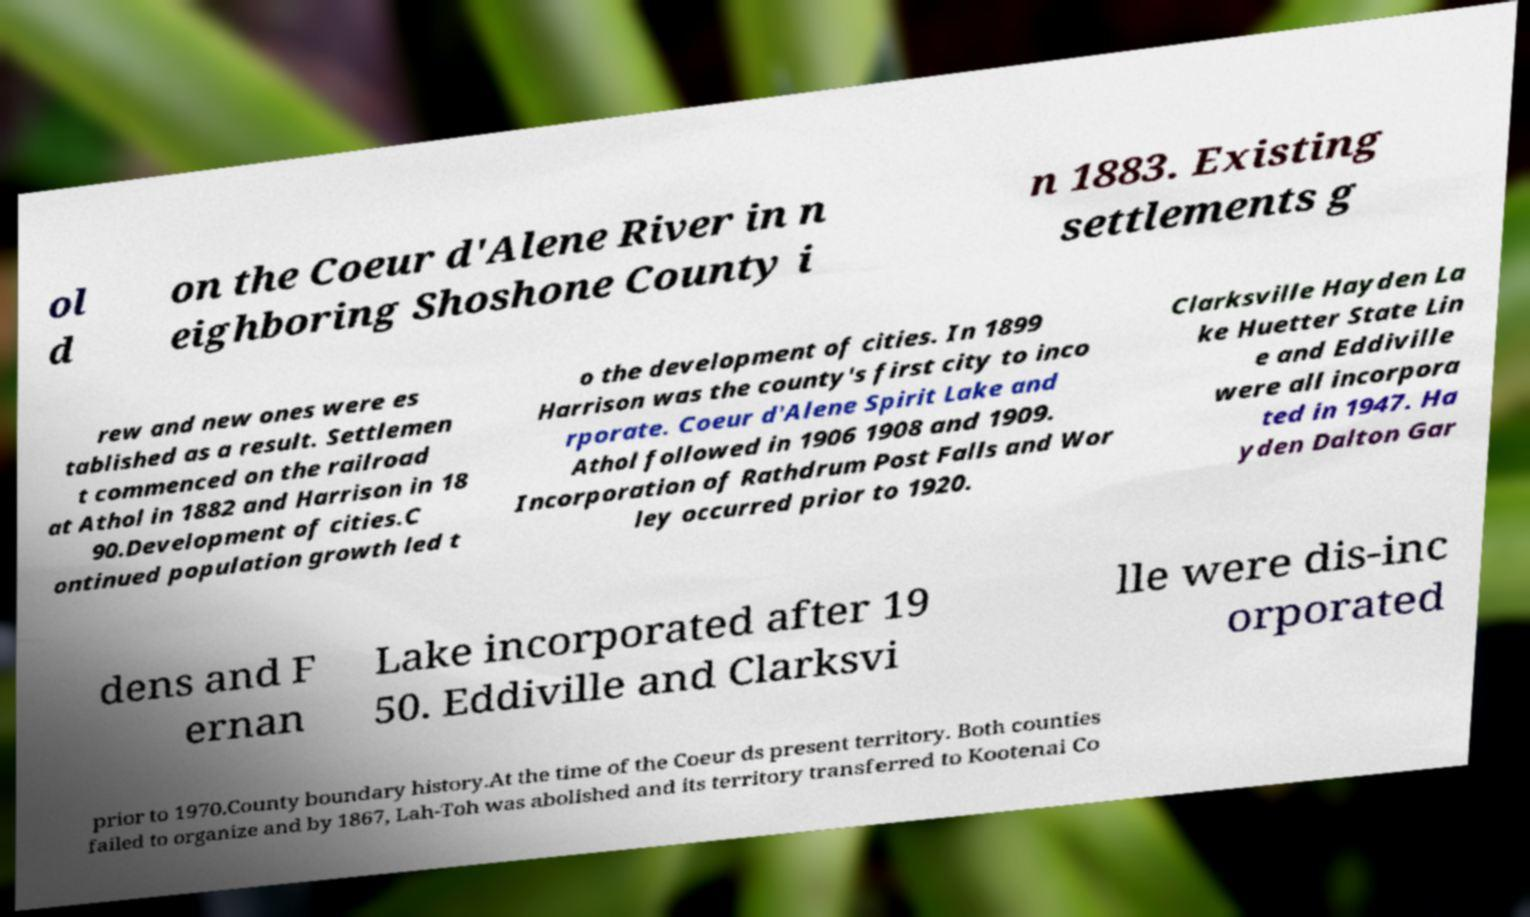Can you accurately transcribe the text from the provided image for me? ol d on the Coeur d'Alene River in n eighboring Shoshone County i n 1883. Existing settlements g rew and new ones were es tablished as a result. Settlemen t commenced on the railroad at Athol in 1882 and Harrison in 18 90.Development of cities.C ontinued population growth led t o the development of cities. In 1899 Harrison was the county's first city to inco rporate. Coeur d'Alene Spirit Lake and Athol followed in 1906 1908 and 1909. Incorporation of Rathdrum Post Falls and Wor ley occurred prior to 1920. Clarksville Hayden La ke Huetter State Lin e and Eddiville were all incorpora ted in 1947. Ha yden Dalton Gar dens and F ernan Lake incorporated after 19 50. Eddiville and Clarksvi lle were dis-inc orporated prior to 1970.County boundary history.At the time of the Coeur ds present territory. Both counties failed to organize and by 1867, Lah-Toh was abolished and its territory transferred to Kootenai Co 